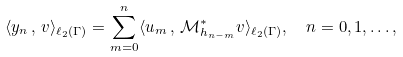Convert formula to latex. <formula><loc_0><loc_0><loc_500><loc_500>\langle y _ { n } \, , \, v \rangle _ { \ell _ { 2 } ( \Gamma ) } & = \sum _ { m = 0 } ^ { n } \langle u _ { m } \, , \, \mathcal { M } _ { h _ { n - m } } ^ { * } v \rangle _ { \ell _ { 2 } ( \Gamma ) } , \quad n = 0 , 1 , \dots ,</formula> 